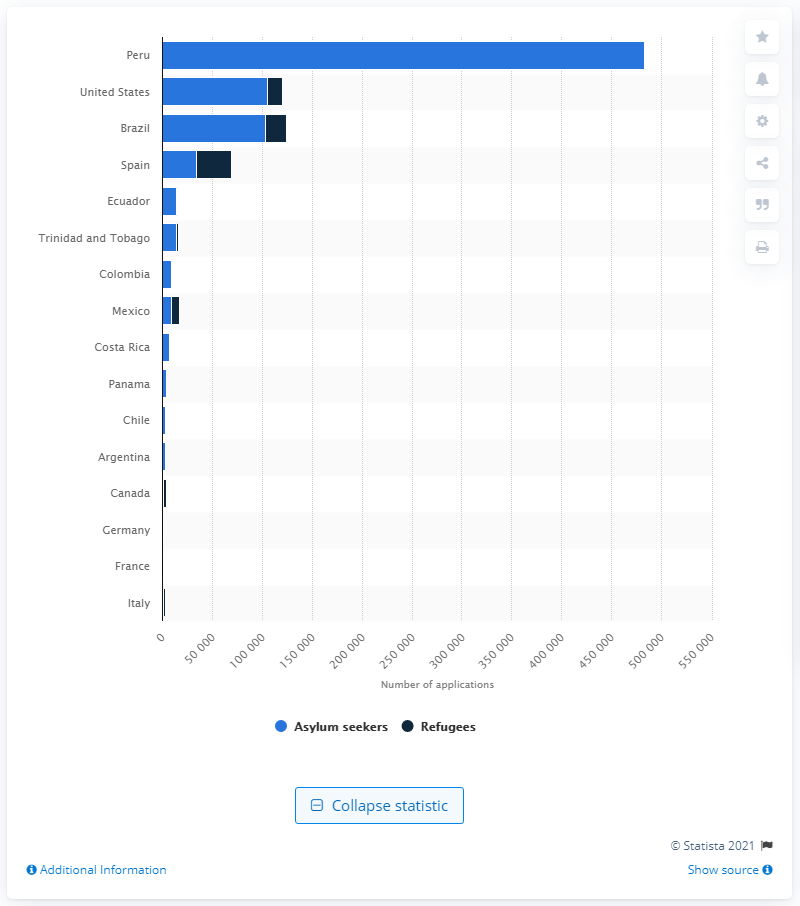Indicate a few pertinent items in this graphic. Peru had the highest number of Venezuelan asylum applications in 2019, according to data. Spain is the country that has registered the largest number of Venezuelans with recognized refugee status. 